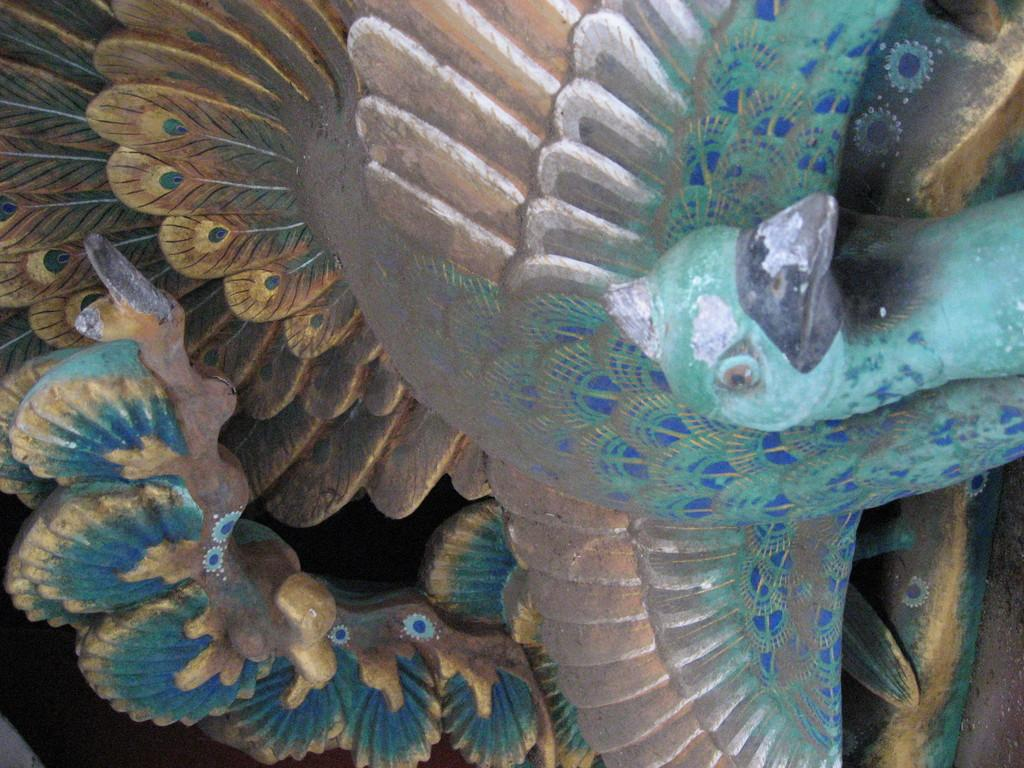What is the main subject of the image? There is a sculpture in the image. What type of animal is depicted in the sculpture? The sculpture is of a peacock. Can you describe the design of the peacock sculpture? The peacock sculpture has a colorful design. What type of material is the skirt made of in the image? There is no skirt present in the image; it features a sculpture of a peacock. 